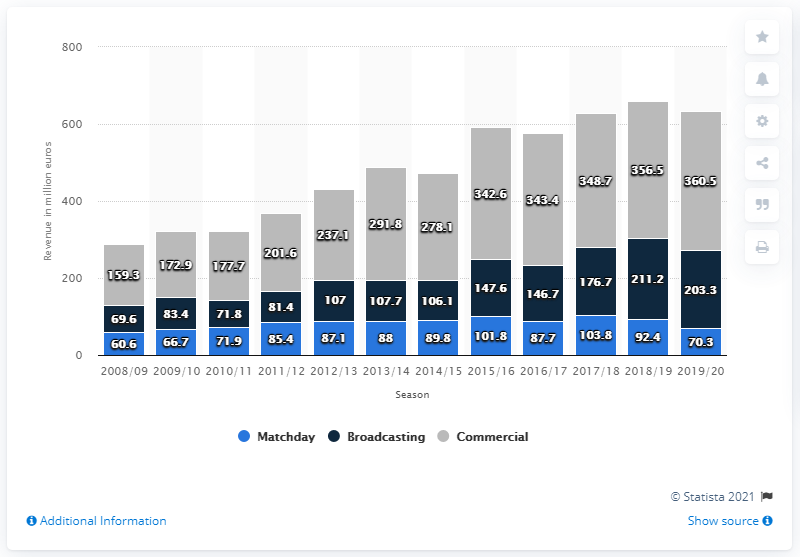Mention a couple of crucial points in this snapshot. In the past decade, Bayern Munich generated a total of 360.5 million euros in commercial deals. 